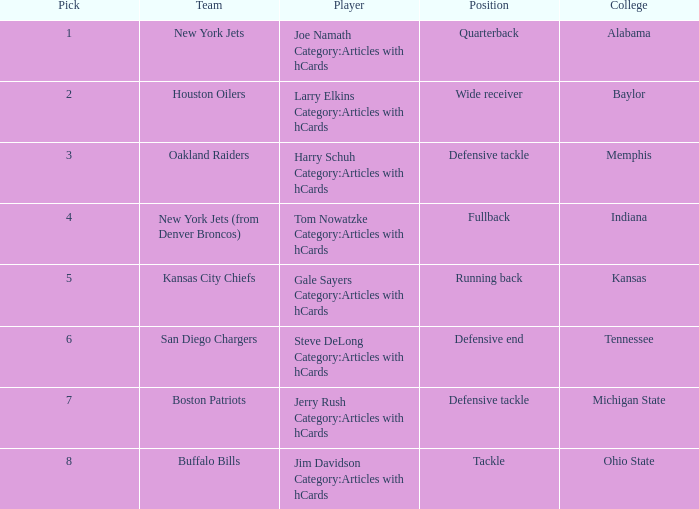Which athlete is from ohio state college? Jim Davidson Category:Articles with hCards. 